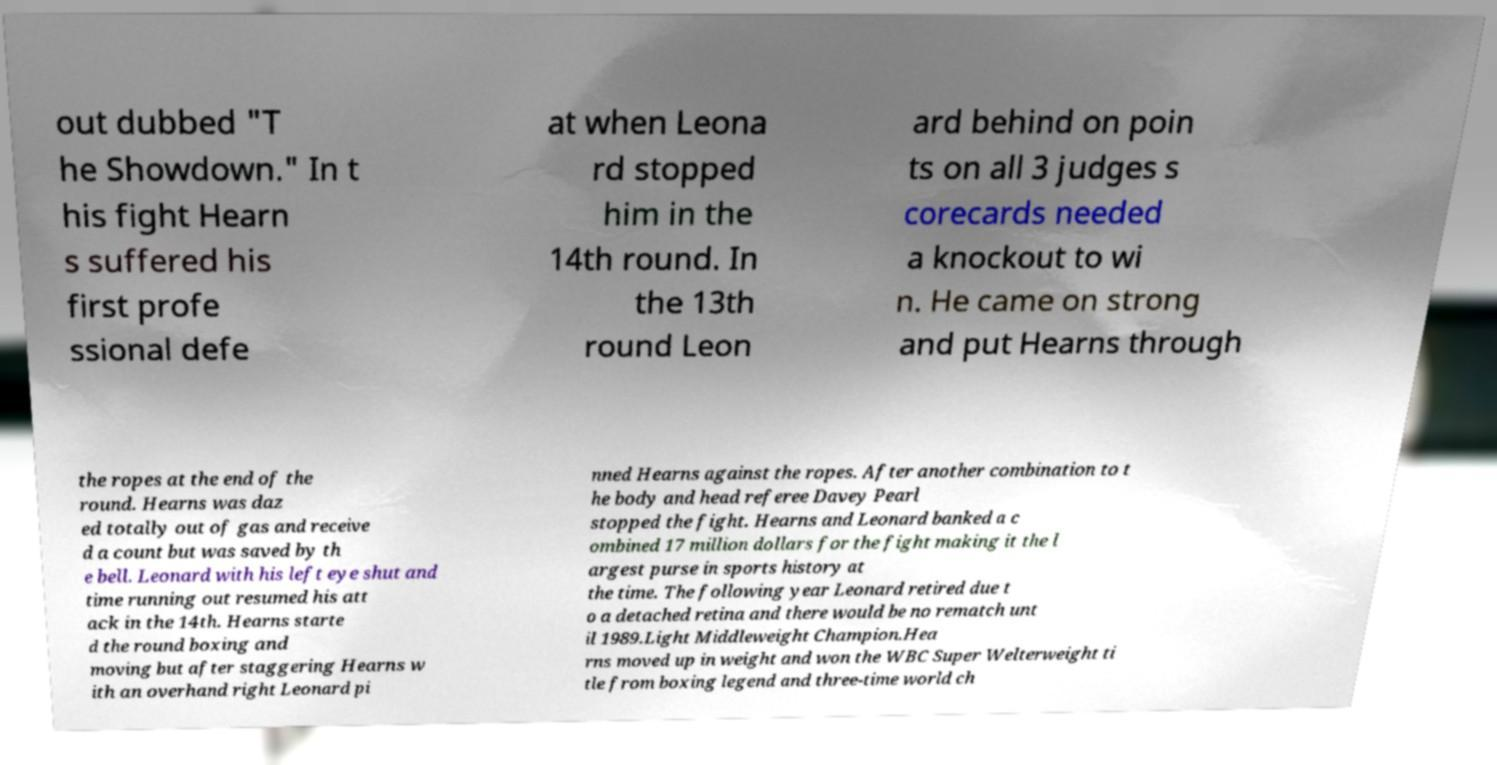What messages or text are displayed in this image? I need them in a readable, typed format. out dubbed "T he Showdown." In t his fight Hearn s suffered his first profe ssional defe at when Leona rd stopped him in the 14th round. In the 13th round Leon ard behind on poin ts on all 3 judges s corecards needed a knockout to wi n. He came on strong and put Hearns through the ropes at the end of the round. Hearns was daz ed totally out of gas and receive d a count but was saved by th e bell. Leonard with his left eye shut and time running out resumed his att ack in the 14th. Hearns starte d the round boxing and moving but after staggering Hearns w ith an overhand right Leonard pi nned Hearns against the ropes. After another combination to t he body and head referee Davey Pearl stopped the fight. Hearns and Leonard banked a c ombined 17 million dollars for the fight making it the l argest purse in sports history at the time. The following year Leonard retired due t o a detached retina and there would be no rematch unt il 1989.Light Middleweight Champion.Hea rns moved up in weight and won the WBC Super Welterweight ti tle from boxing legend and three-time world ch 